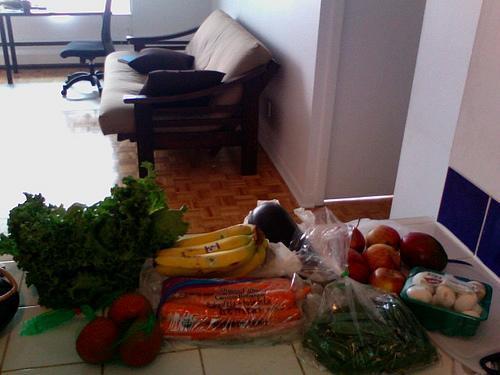How many oranges are in this picture?
Give a very brief answer. 0. 